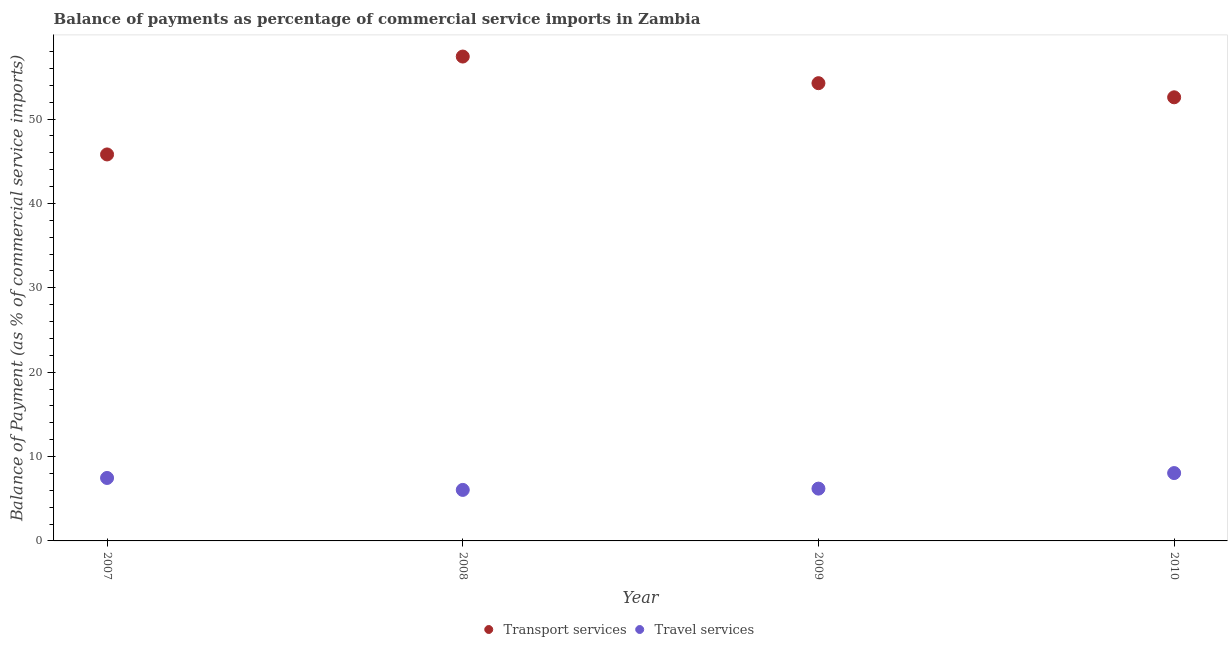How many different coloured dotlines are there?
Provide a succinct answer. 2. What is the balance of payments of travel services in 2010?
Ensure brevity in your answer.  8.04. Across all years, what is the maximum balance of payments of transport services?
Ensure brevity in your answer.  57.42. Across all years, what is the minimum balance of payments of transport services?
Make the answer very short. 45.81. In which year was the balance of payments of travel services maximum?
Your answer should be compact. 2010. In which year was the balance of payments of travel services minimum?
Your answer should be compact. 2008. What is the total balance of payments of transport services in the graph?
Your answer should be compact. 210.08. What is the difference between the balance of payments of travel services in 2008 and that in 2010?
Your answer should be compact. -2. What is the difference between the balance of payments of travel services in 2010 and the balance of payments of transport services in 2009?
Your answer should be very brief. -46.22. What is the average balance of payments of travel services per year?
Provide a short and direct response. 6.94. In the year 2008, what is the difference between the balance of payments of transport services and balance of payments of travel services?
Ensure brevity in your answer.  51.37. In how many years, is the balance of payments of transport services greater than 22 %?
Give a very brief answer. 4. What is the ratio of the balance of payments of travel services in 2007 to that in 2010?
Keep it short and to the point. 0.93. Is the difference between the balance of payments of travel services in 2008 and 2010 greater than the difference between the balance of payments of transport services in 2008 and 2010?
Your answer should be compact. No. What is the difference between the highest and the second highest balance of payments of travel services?
Your response must be concise. 0.58. What is the difference between the highest and the lowest balance of payments of transport services?
Your response must be concise. 11.6. In how many years, is the balance of payments of transport services greater than the average balance of payments of transport services taken over all years?
Ensure brevity in your answer.  3. Is the sum of the balance of payments of transport services in 2007 and 2010 greater than the maximum balance of payments of travel services across all years?
Provide a succinct answer. Yes. Is the balance of payments of transport services strictly less than the balance of payments of travel services over the years?
Offer a very short reply. No. How many dotlines are there?
Provide a short and direct response. 2. What is the difference between two consecutive major ticks on the Y-axis?
Give a very brief answer. 10. Are the values on the major ticks of Y-axis written in scientific E-notation?
Ensure brevity in your answer.  No. Does the graph contain grids?
Keep it short and to the point. No. How many legend labels are there?
Offer a very short reply. 2. How are the legend labels stacked?
Give a very brief answer. Horizontal. What is the title of the graph?
Your response must be concise. Balance of payments as percentage of commercial service imports in Zambia. Does "Short-term debt" appear as one of the legend labels in the graph?
Provide a succinct answer. No. What is the label or title of the X-axis?
Offer a terse response. Year. What is the label or title of the Y-axis?
Your response must be concise. Balance of Payment (as % of commercial service imports). What is the Balance of Payment (as % of commercial service imports) of Transport services in 2007?
Provide a succinct answer. 45.81. What is the Balance of Payment (as % of commercial service imports) in Travel services in 2007?
Offer a terse response. 7.46. What is the Balance of Payment (as % of commercial service imports) of Transport services in 2008?
Provide a short and direct response. 57.42. What is the Balance of Payment (as % of commercial service imports) in Travel services in 2008?
Your response must be concise. 6.05. What is the Balance of Payment (as % of commercial service imports) in Transport services in 2009?
Provide a short and direct response. 54.26. What is the Balance of Payment (as % of commercial service imports) of Travel services in 2009?
Keep it short and to the point. 6.2. What is the Balance of Payment (as % of commercial service imports) of Transport services in 2010?
Provide a succinct answer. 52.59. What is the Balance of Payment (as % of commercial service imports) in Travel services in 2010?
Provide a short and direct response. 8.04. Across all years, what is the maximum Balance of Payment (as % of commercial service imports) in Transport services?
Provide a succinct answer. 57.42. Across all years, what is the maximum Balance of Payment (as % of commercial service imports) in Travel services?
Provide a short and direct response. 8.04. Across all years, what is the minimum Balance of Payment (as % of commercial service imports) in Transport services?
Ensure brevity in your answer.  45.81. Across all years, what is the minimum Balance of Payment (as % of commercial service imports) of Travel services?
Your response must be concise. 6.05. What is the total Balance of Payment (as % of commercial service imports) of Transport services in the graph?
Keep it short and to the point. 210.08. What is the total Balance of Payment (as % of commercial service imports) of Travel services in the graph?
Offer a terse response. 27.75. What is the difference between the Balance of Payment (as % of commercial service imports) of Transport services in 2007 and that in 2008?
Offer a very short reply. -11.6. What is the difference between the Balance of Payment (as % of commercial service imports) in Travel services in 2007 and that in 2008?
Your response must be concise. 1.42. What is the difference between the Balance of Payment (as % of commercial service imports) in Transport services in 2007 and that in 2009?
Provide a succinct answer. -8.45. What is the difference between the Balance of Payment (as % of commercial service imports) of Travel services in 2007 and that in 2009?
Your answer should be compact. 1.26. What is the difference between the Balance of Payment (as % of commercial service imports) in Transport services in 2007 and that in 2010?
Your answer should be very brief. -6.77. What is the difference between the Balance of Payment (as % of commercial service imports) in Travel services in 2007 and that in 2010?
Your answer should be compact. -0.58. What is the difference between the Balance of Payment (as % of commercial service imports) in Transport services in 2008 and that in 2009?
Provide a short and direct response. 3.16. What is the difference between the Balance of Payment (as % of commercial service imports) of Travel services in 2008 and that in 2009?
Provide a succinct answer. -0.15. What is the difference between the Balance of Payment (as % of commercial service imports) in Transport services in 2008 and that in 2010?
Your answer should be very brief. 4.83. What is the difference between the Balance of Payment (as % of commercial service imports) in Travel services in 2008 and that in 2010?
Your response must be concise. -2. What is the difference between the Balance of Payment (as % of commercial service imports) in Transport services in 2009 and that in 2010?
Give a very brief answer. 1.67. What is the difference between the Balance of Payment (as % of commercial service imports) in Travel services in 2009 and that in 2010?
Give a very brief answer. -1.84. What is the difference between the Balance of Payment (as % of commercial service imports) in Transport services in 2007 and the Balance of Payment (as % of commercial service imports) in Travel services in 2008?
Offer a terse response. 39.77. What is the difference between the Balance of Payment (as % of commercial service imports) of Transport services in 2007 and the Balance of Payment (as % of commercial service imports) of Travel services in 2009?
Provide a short and direct response. 39.61. What is the difference between the Balance of Payment (as % of commercial service imports) in Transport services in 2007 and the Balance of Payment (as % of commercial service imports) in Travel services in 2010?
Provide a succinct answer. 37.77. What is the difference between the Balance of Payment (as % of commercial service imports) in Transport services in 2008 and the Balance of Payment (as % of commercial service imports) in Travel services in 2009?
Keep it short and to the point. 51.22. What is the difference between the Balance of Payment (as % of commercial service imports) in Transport services in 2008 and the Balance of Payment (as % of commercial service imports) in Travel services in 2010?
Give a very brief answer. 49.37. What is the difference between the Balance of Payment (as % of commercial service imports) of Transport services in 2009 and the Balance of Payment (as % of commercial service imports) of Travel services in 2010?
Offer a terse response. 46.22. What is the average Balance of Payment (as % of commercial service imports) of Transport services per year?
Offer a very short reply. 52.52. What is the average Balance of Payment (as % of commercial service imports) of Travel services per year?
Offer a terse response. 6.94. In the year 2007, what is the difference between the Balance of Payment (as % of commercial service imports) of Transport services and Balance of Payment (as % of commercial service imports) of Travel services?
Provide a short and direct response. 38.35. In the year 2008, what is the difference between the Balance of Payment (as % of commercial service imports) in Transport services and Balance of Payment (as % of commercial service imports) in Travel services?
Offer a very short reply. 51.37. In the year 2009, what is the difference between the Balance of Payment (as % of commercial service imports) in Transport services and Balance of Payment (as % of commercial service imports) in Travel services?
Provide a succinct answer. 48.06. In the year 2010, what is the difference between the Balance of Payment (as % of commercial service imports) of Transport services and Balance of Payment (as % of commercial service imports) of Travel services?
Provide a short and direct response. 44.54. What is the ratio of the Balance of Payment (as % of commercial service imports) of Transport services in 2007 to that in 2008?
Offer a very short reply. 0.8. What is the ratio of the Balance of Payment (as % of commercial service imports) in Travel services in 2007 to that in 2008?
Keep it short and to the point. 1.23. What is the ratio of the Balance of Payment (as % of commercial service imports) of Transport services in 2007 to that in 2009?
Give a very brief answer. 0.84. What is the ratio of the Balance of Payment (as % of commercial service imports) in Travel services in 2007 to that in 2009?
Make the answer very short. 1.2. What is the ratio of the Balance of Payment (as % of commercial service imports) of Transport services in 2007 to that in 2010?
Ensure brevity in your answer.  0.87. What is the ratio of the Balance of Payment (as % of commercial service imports) of Travel services in 2007 to that in 2010?
Keep it short and to the point. 0.93. What is the ratio of the Balance of Payment (as % of commercial service imports) in Transport services in 2008 to that in 2009?
Keep it short and to the point. 1.06. What is the ratio of the Balance of Payment (as % of commercial service imports) in Travel services in 2008 to that in 2009?
Give a very brief answer. 0.98. What is the ratio of the Balance of Payment (as % of commercial service imports) of Transport services in 2008 to that in 2010?
Your answer should be compact. 1.09. What is the ratio of the Balance of Payment (as % of commercial service imports) in Travel services in 2008 to that in 2010?
Your answer should be very brief. 0.75. What is the ratio of the Balance of Payment (as % of commercial service imports) of Transport services in 2009 to that in 2010?
Keep it short and to the point. 1.03. What is the ratio of the Balance of Payment (as % of commercial service imports) of Travel services in 2009 to that in 2010?
Your response must be concise. 0.77. What is the difference between the highest and the second highest Balance of Payment (as % of commercial service imports) of Transport services?
Offer a very short reply. 3.16. What is the difference between the highest and the second highest Balance of Payment (as % of commercial service imports) in Travel services?
Your answer should be compact. 0.58. What is the difference between the highest and the lowest Balance of Payment (as % of commercial service imports) in Transport services?
Offer a very short reply. 11.6. What is the difference between the highest and the lowest Balance of Payment (as % of commercial service imports) of Travel services?
Provide a succinct answer. 2. 